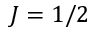<formula> <loc_0><loc_0><loc_500><loc_500>J = 1 / 2</formula> 